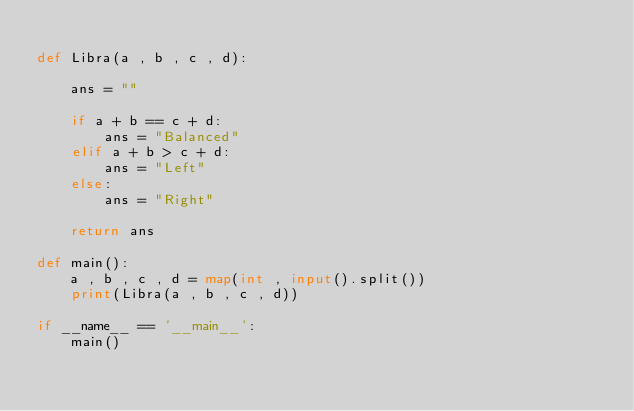<code> <loc_0><loc_0><loc_500><loc_500><_Python_>
def Libra(a , b , c , d):

    ans = ""

    if a + b == c + d:
        ans = "Balanced"
    elif a + b > c + d:
        ans = "Left"
    else:
        ans = "Right"
    
    return ans

def main():
    a , b , c , d = map(int , input().split())
    print(Libra(a , b , c , d))

if __name__ == '__main__':
    main()
</code> 